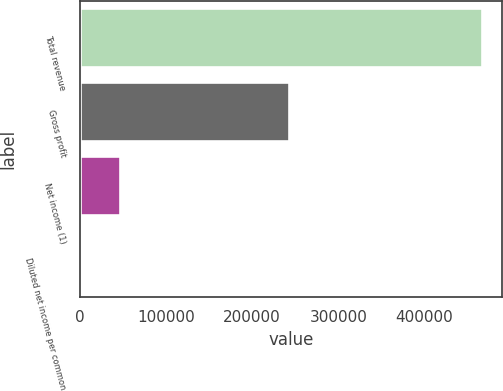Convert chart. <chart><loc_0><loc_0><loc_500><loc_500><bar_chart><fcel>Total revenue<fcel>Gross profit<fcel>Net income (1)<fcel>Diluted net income per common<nl><fcel>467045<fcel>243199<fcel>46704.6<fcel>0.1<nl></chart> 